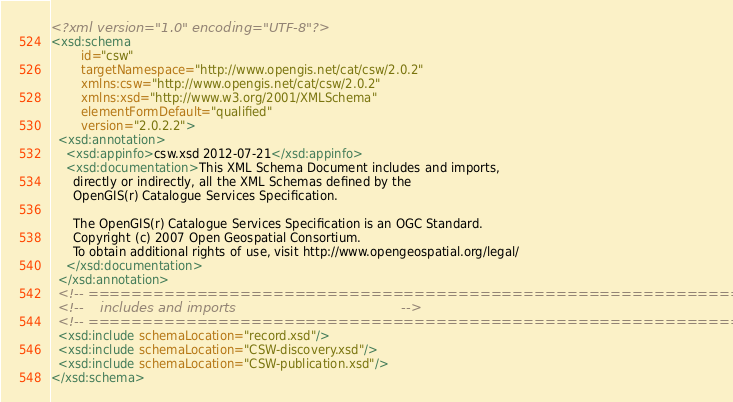Convert code to text. <code><loc_0><loc_0><loc_500><loc_500><_XML_><?xml version="1.0" encoding="UTF-8"?>
<xsd:schema
        id="csw"
        targetNamespace="http://www.opengis.net/cat/csw/2.0.2"
        xmlns:csw="http://www.opengis.net/cat/csw/2.0.2"
        xmlns:xsd="http://www.w3.org/2001/XMLSchema"
        elementFormDefault="qualified"
        version="2.0.2.2">
  <xsd:annotation>
    <xsd:appinfo>csw.xsd 2012-07-21</xsd:appinfo>
    <xsd:documentation>This XML Schema Document includes and imports,
      directly or indirectly, all the XML Schemas defined by the
      OpenGIS(r) Catalogue Services Specification.

      The OpenGIS(r) Catalogue Services Specification is an OGC Standard.
      Copyright (c) 2007 Open Geospatial Consortium.
      To obtain additional rights of use, visit http://www.opengeospatial.org/legal/
    </xsd:documentation>
  </xsd:annotation>
  <!-- ============================================================== -->
  <!--    includes and imports                                        -->
  <!-- ============================================================== -->
  <xsd:include schemaLocation="record.xsd"/>
  <xsd:include schemaLocation="CSW-discovery.xsd"/>
  <xsd:include schemaLocation="CSW-publication.xsd"/>
</xsd:schema></code> 